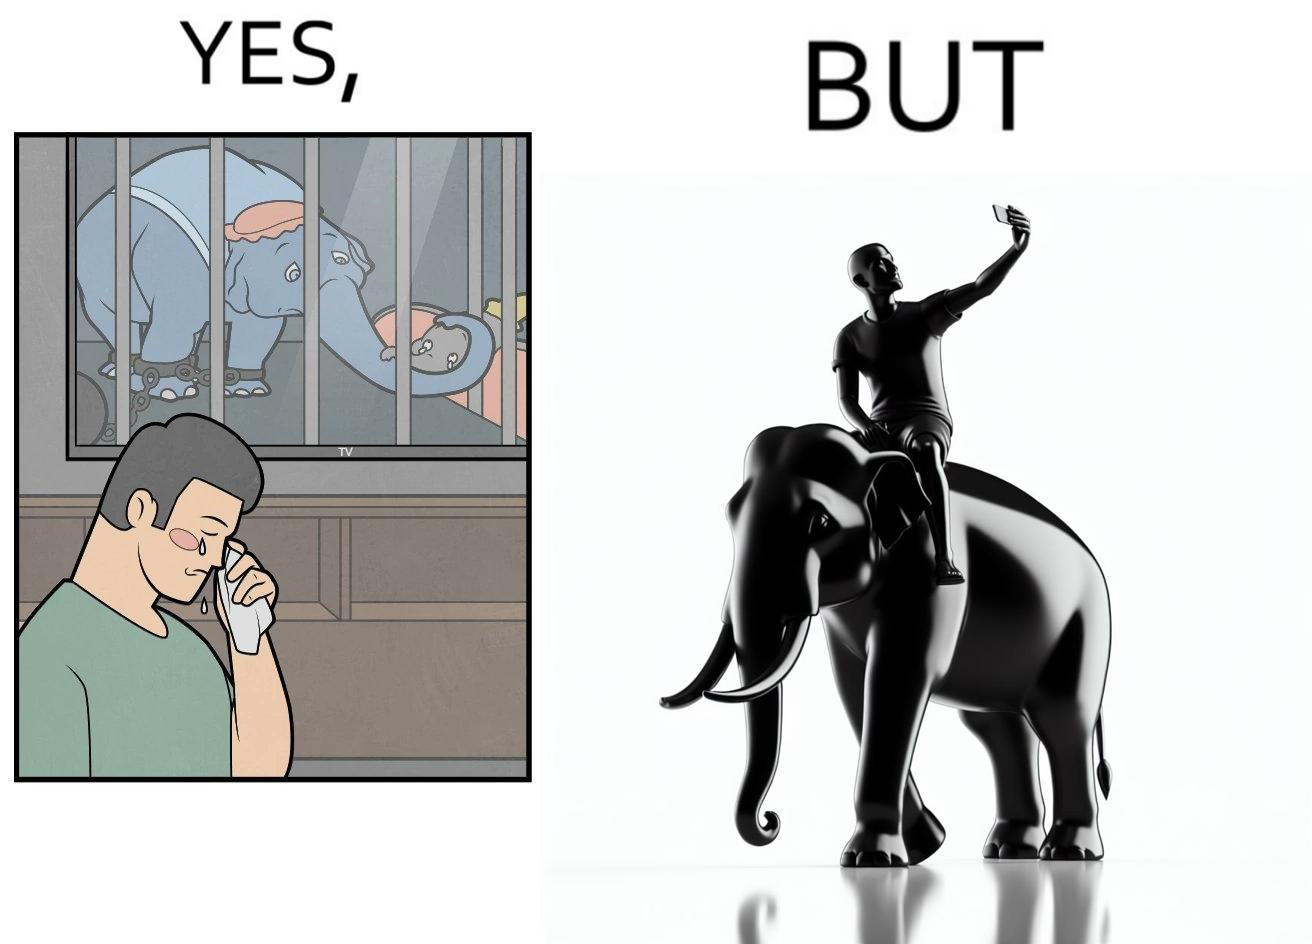What makes this image funny or satirical? The image is ironic, because the people who get sentimental over imprisoned animal while watching TV shows often feel okay when using animals for labor 